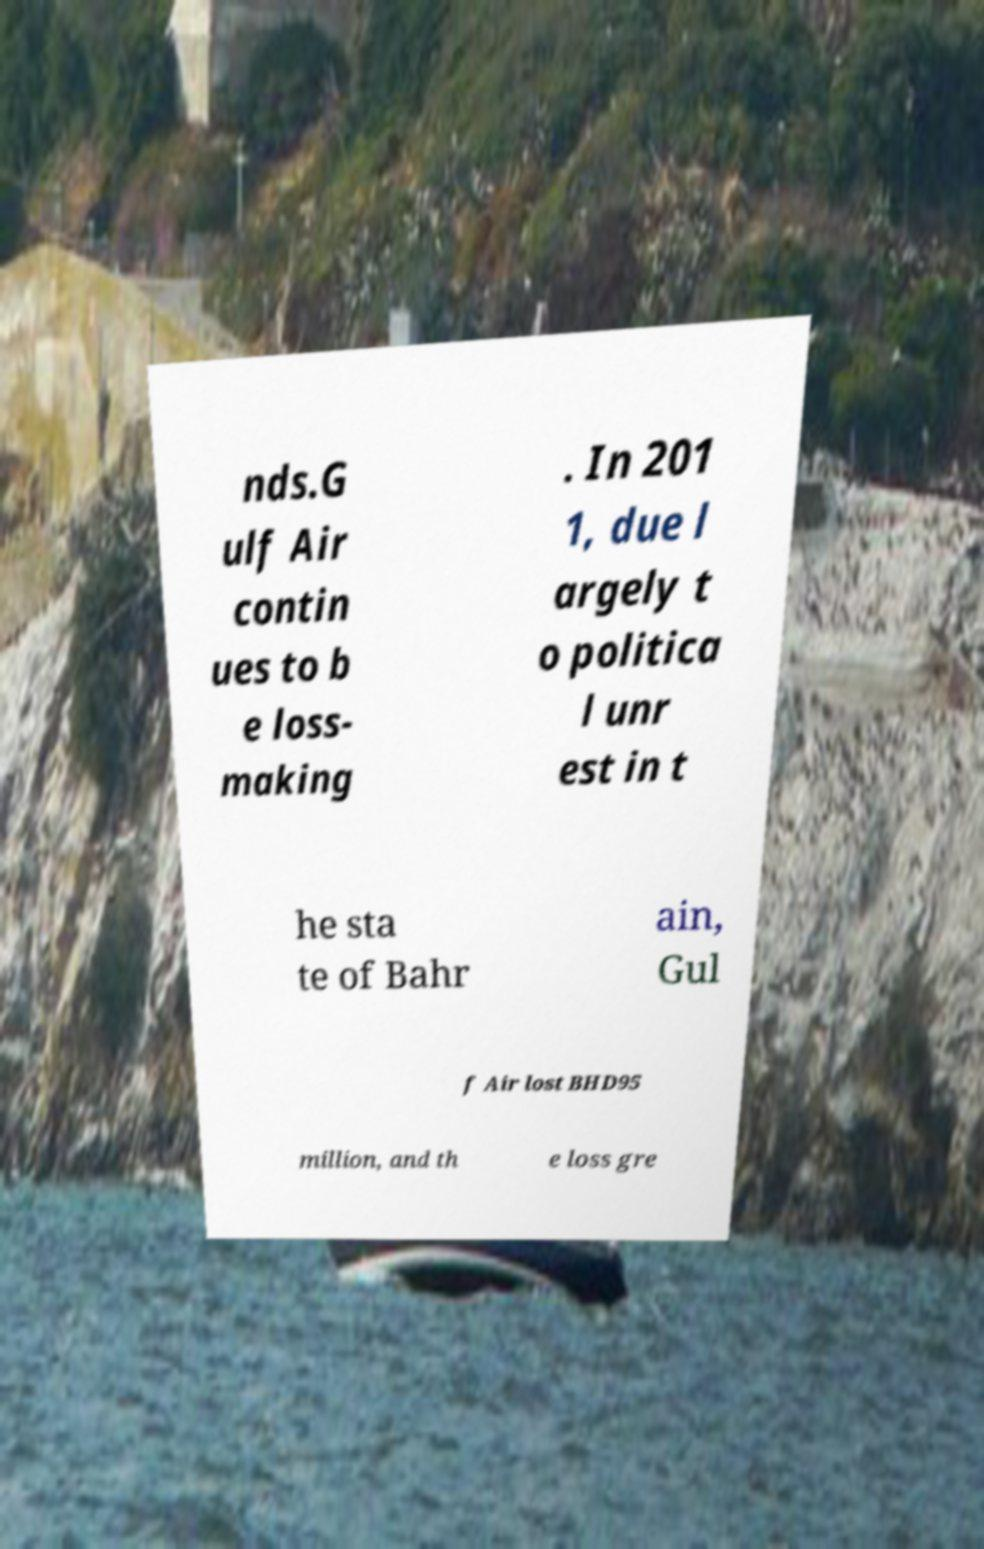Can you accurately transcribe the text from the provided image for me? nds.G ulf Air contin ues to b e loss- making . In 201 1, due l argely t o politica l unr est in t he sta te of Bahr ain, Gul f Air lost BHD95 million, and th e loss gre 